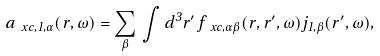<formula> <loc_0><loc_0><loc_500><loc_500>a _ { \ x c , 1 , \alpha } ( { r } , \omega ) = \sum _ { \beta } \, \int d ^ { 3 } r ^ { \prime } \, f _ { \ x c , \alpha \beta } ( { r } , { r } ^ { \prime } , \omega ) j _ { 1 , \beta } ( { r } ^ { \prime } , \omega ) ,</formula> 